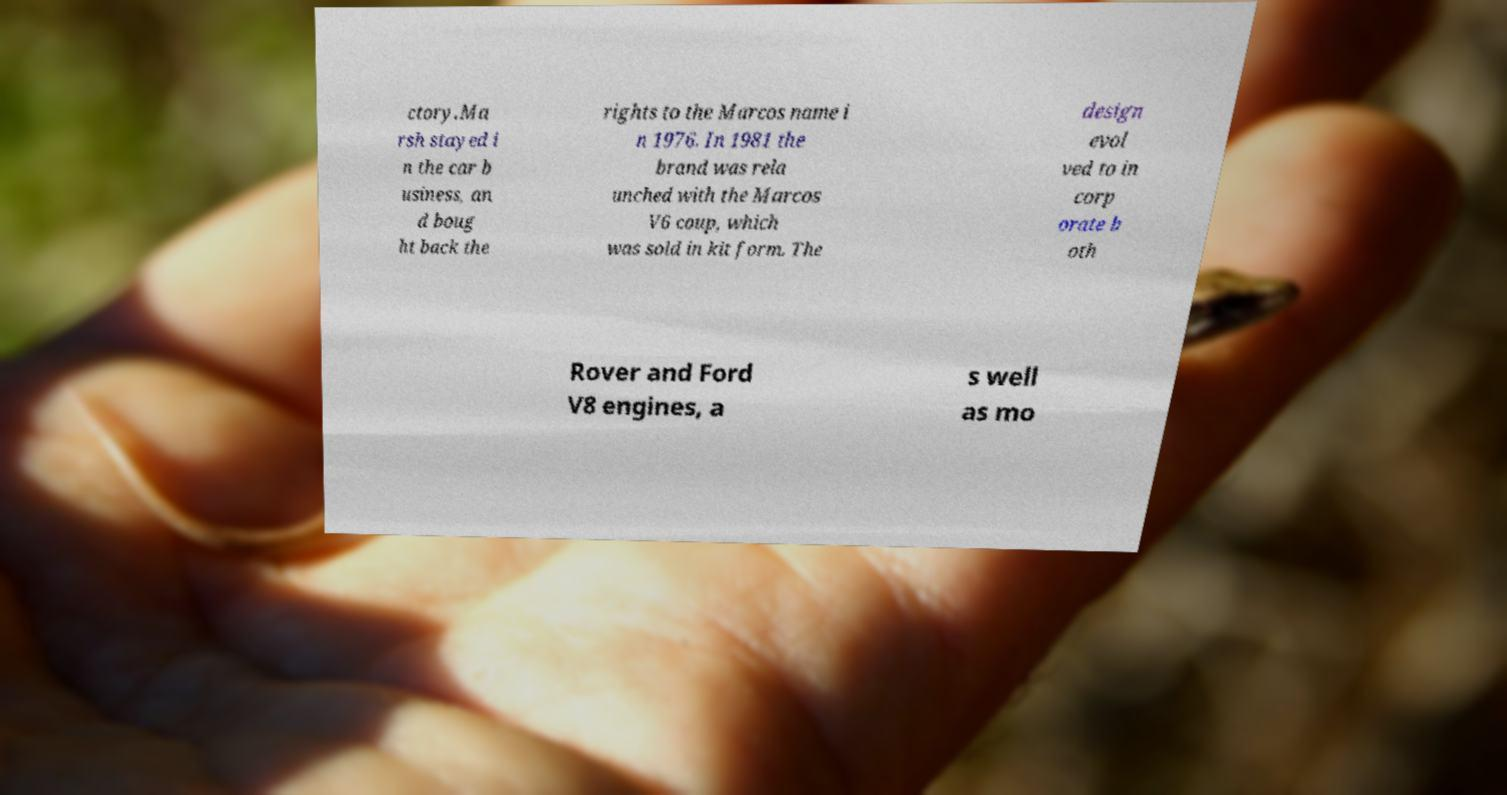Can you read and provide the text displayed in the image?This photo seems to have some interesting text. Can you extract and type it out for me? ctory.Ma rsh stayed i n the car b usiness, an d boug ht back the rights to the Marcos name i n 1976. In 1981 the brand was rela unched with the Marcos V6 coup, which was sold in kit form. The design evol ved to in corp orate b oth Rover and Ford V8 engines, a s well as mo 